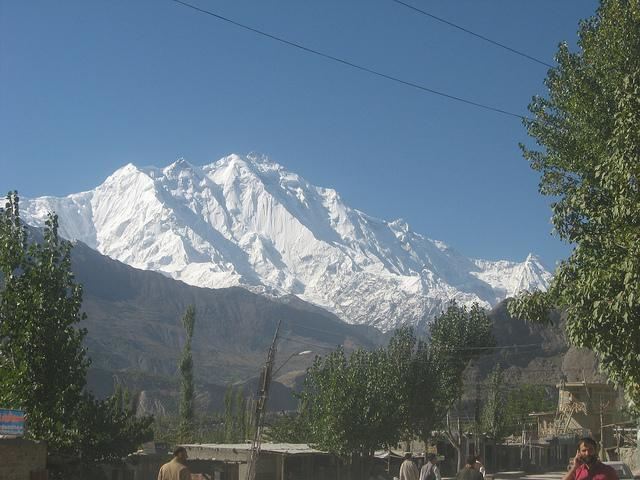Why is there snow up there?

Choices:
A) storm coming
B) high altitude
C) is mirage
D) not shoveled high altitude 